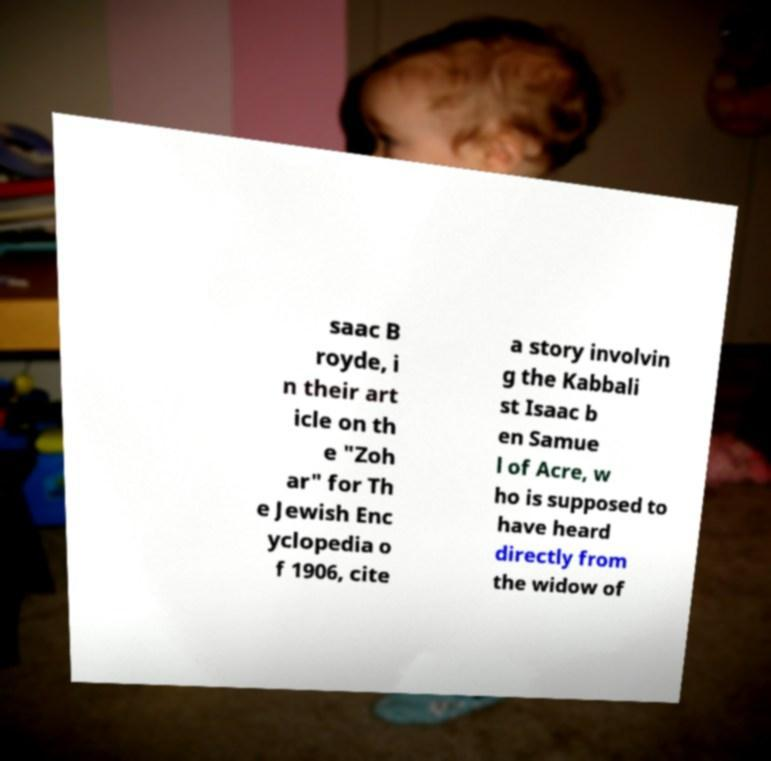What messages or text are displayed in this image? I need them in a readable, typed format. saac B royde, i n their art icle on th e "Zoh ar" for Th e Jewish Enc yclopedia o f 1906, cite a story involvin g the Kabbali st Isaac b en Samue l of Acre, w ho is supposed to have heard directly from the widow of 